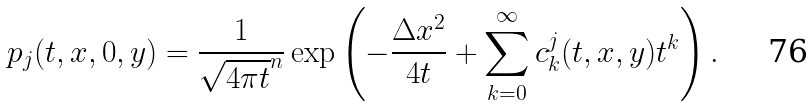Convert formula to latex. <formula><loc_0><loc_0><loc_500><loc_500>p _ { j } ( t , x , 0 , y ) = \frac { 1 } { \sqrt { 4 \pi t } ^ { n } } \exp \left ( - \frac { \Delta x ^ { 2 } } { 4 t } + \sum _ { k = 0 } ^ { \infty } c ^ { j } _ { k } ( t , x , y ) t ^ { k } \right ) .</formula> 